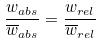<formula> <loc_0><loc_0><loc_500><loc_500>\frac { w _ { a b s } } { \overline { w } _ { a b s } } = \frac { w _ { r e l } } { \overline { w } _ { r e l } }</formula> 